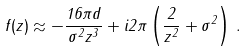<formula> <loc_0><loc_0><loc_500><loc_500>f ( z ) \approx - \frac { 1 6 \pi d } { \sigma ^ { 2 } z ^ { 3 } } + i 2 \pi \left ( \frac { 2 } { z ^ { 2 } } + \sigma ^ { 2 } \right ) \, .</formula> 